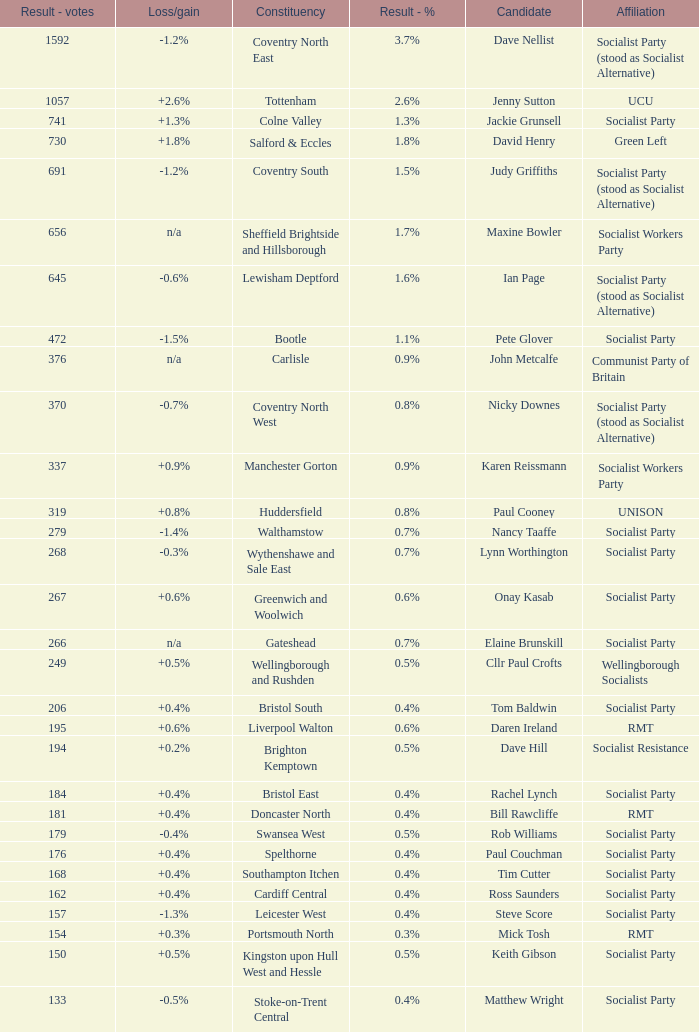What is the largest vote result for the Huddersfield constituency? 319.0. 